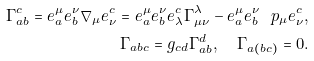<formula> <loc_0><loc_0><loc_500><loc_500>\Gamma ^ { c } _ { a b } = e ^ { \mu } _ { a } e ^ { \nu } _ { b } \nabla _ { \mu } e _ { \nu } ^ { c } = e ^ { \mu } _ { a } e ^ { \nu } _ { b } e ^ { c } _ { \lambda } \Gamma _ { \mu \nu } ^ { \lambda } - e ^ { \mu } _ { a } e ^ { \nu } _ { b } \ p _ { \mu } e ^ { c } _ { \nu } , \\ \Gamma _ { a b c } = g _ { c d } \Gamma _ { a b } ^ { d } , \quad \Gamma _ { a ( b c ) } = 0 .</formula> 